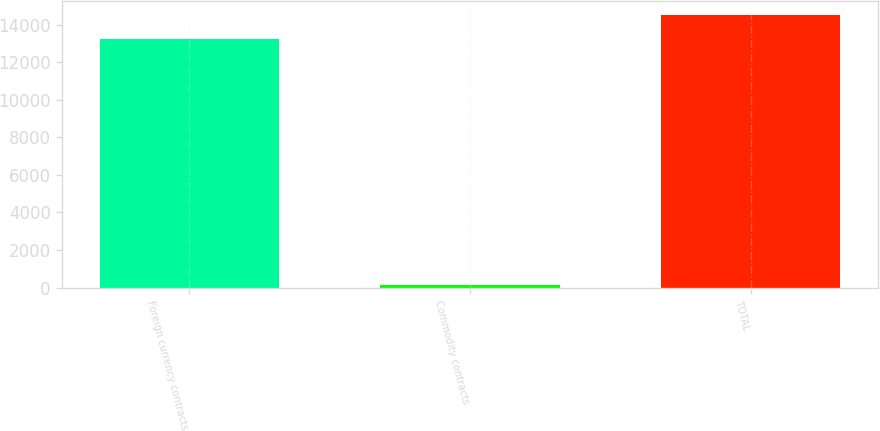<chart> <loc_0><loc_0><loc_500><loc_500><bar_chart><fcel>Foreign currency contracts<fcel>Commodity contracts<fcel>TOTAL<nl><fcel>13210<fcel>125<fcel>14531<nl></chart> 